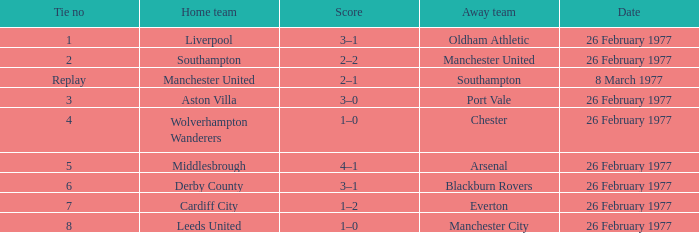Would you be able to parse every entry in this table? {'header': ['Tie no', 'Home team', 'Score', 'Away team', 'Date'], 'rows': [['1', 'Liverpool', '3–1', 'Oldham Athletic', '26 February 1977'], ['2', 'Southampton', '2–2', 'Manchester United', '26 February 1977'], ['Replay', 'Manchester United', '2–1', 'Southampton', '8 March 1977'], ['3', 'Aston Villa', '3–0', 'Port Vale', '26 February 1977'], ['4', 'Wolverhampton Wanderers', '1–0', 'Chester', '26 February 1977'], ['5', 'Middlesbrough', '4–1', 'Arsenal', '26 February 1977'], ['6', 'Derby County', '3–1', 'Blackburn Rovers', '26 February 1977'], ['7', 'Cardiff City', '1–2', 'Everton', '26 February 1977'], ['8', 'Leeds United', '1–0', 'Manchester City', '26 February 1977']]} What day was chester the guest team? 26 February 1977. 